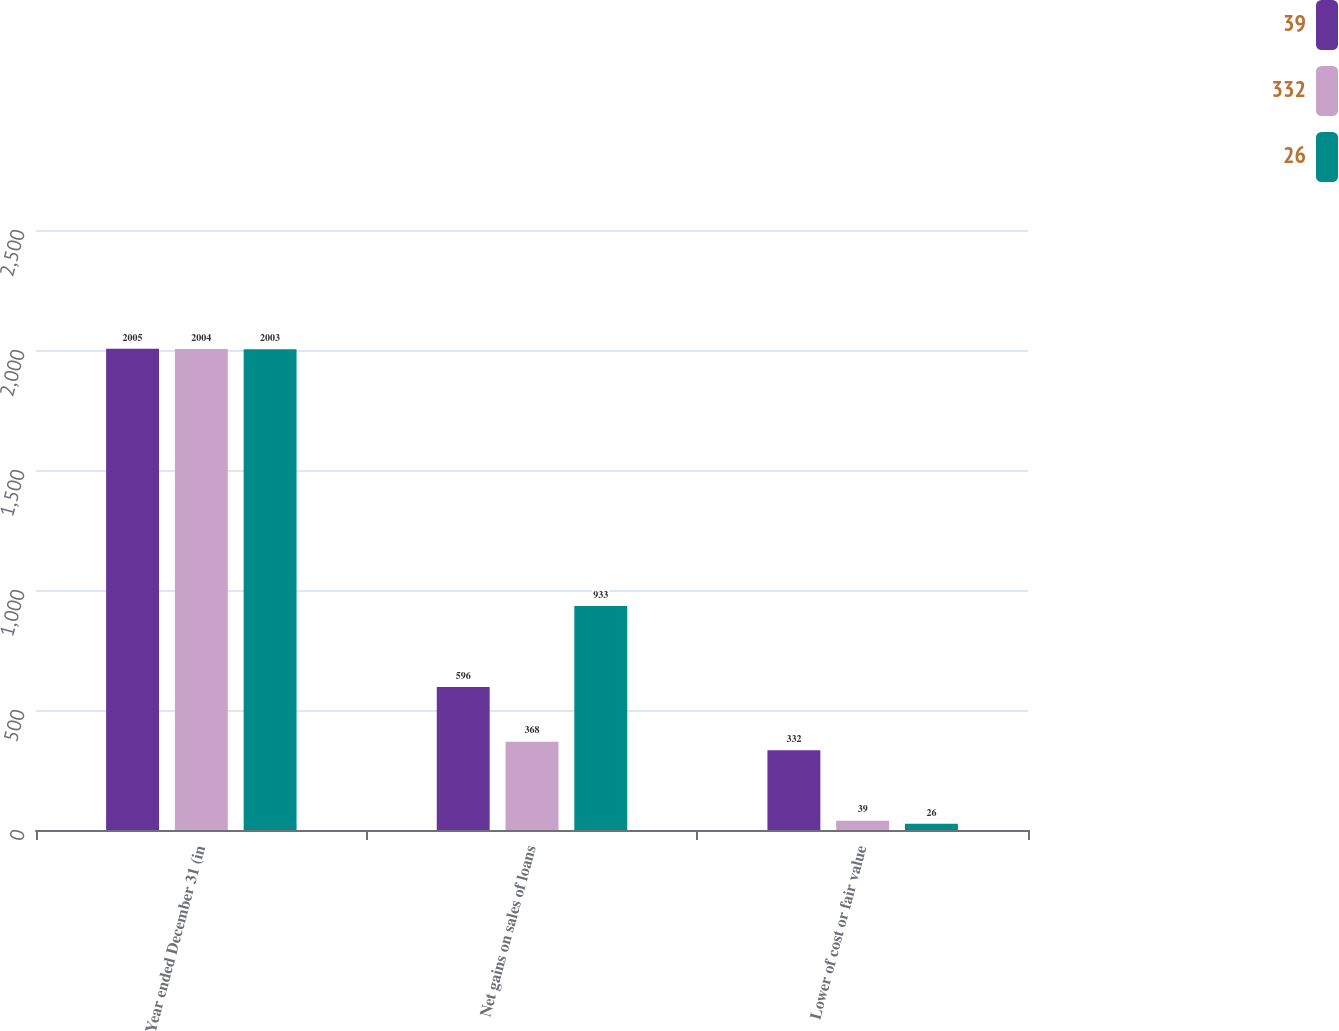<chart> <loc_0><loc_0><loc_500><loc_500><stacked_bar_chart><ecel><fcel>Year ended December 31 (in<fcel>Net gains on sales of loans<fcel>Lower of cost or fair value<nl><fcel>39<fcel>2005<fcel>596<fcel>332<nl><fcel>332<fcel>2004<fcel>368<fcel>39<nl><fcel>26<fcel>2003<fcel>933<fcel>26<nl></chart> 